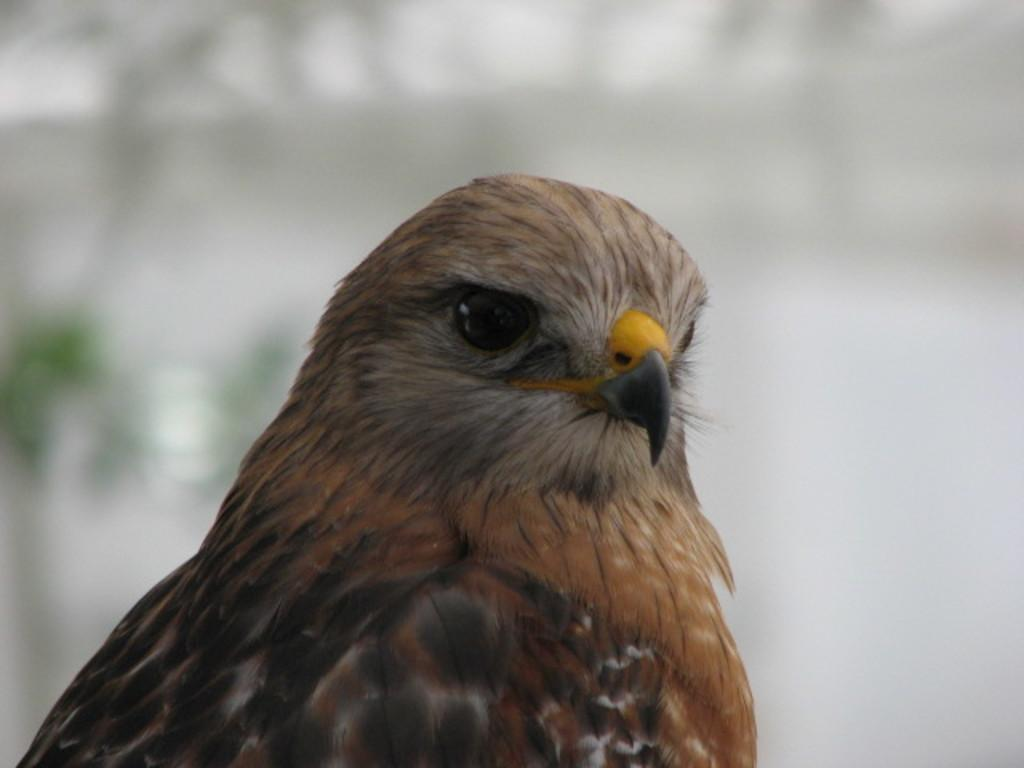What is the color of the bird in the image? The bird in the image is white with some parts brown and black in color. What color is the bird's beak? The bird's beak is yellow and black in color. What does the bird's mouth look like in the image? The bird's mouth is not visible in the image, but its beak is yellow and black in color. Who is the creator of the bird in the image? The facts provided do not give information about the bird's creator, as it is a natural subject. 